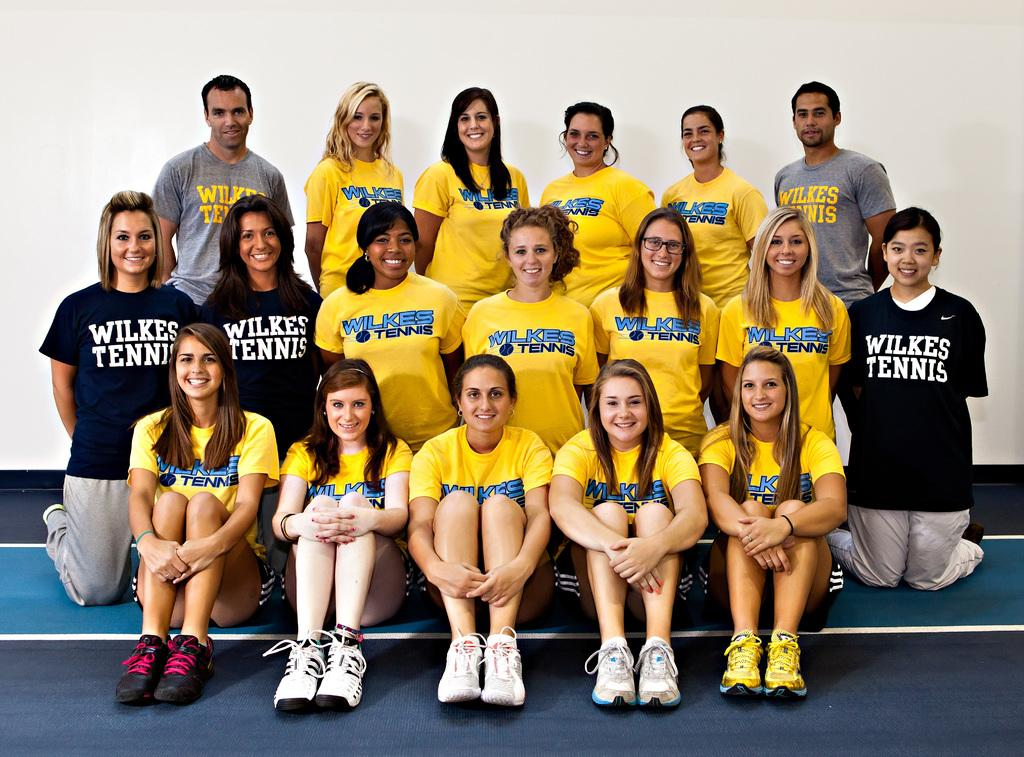<image>
Offer a succinct explanation of the picture presented. The Wilkes Tennis team is posing for a photo. 